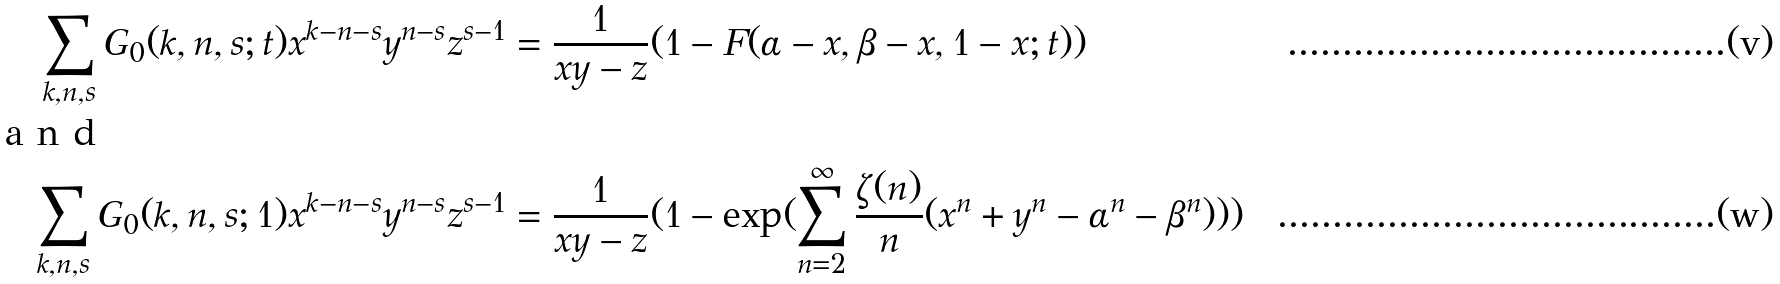<formula> <loc_0><loc_0><loc_500><loc_500>\sum _ { k , n , s } G _ { 0 } ( k , n , s ; t ) x ^ { k - n - s } y ^ { n - s } z ^ { s - 1 } & = \frac { 1 } { x y - z } ( 1 - F ( \alpha - x , \beta - x , 1 - x ; t ) ) \\ \intertext { a n d } \sum _ { k , n , s } G _ { 0 } ( k , n , s ; 1 ) x ^ { k - n - s } y ^ { n - s } z ^ { s - 1 } & = \frac { 1 } { x y - z } ( 1 - \exp ( \sum _ { n = 2 } ^ { \infty } \frac { \zeta ( n ) } { n } ( x ^ { n } + y ^ { n } - \alpha ^ { n } - \beta ^ { n } ) ) )</formula> 